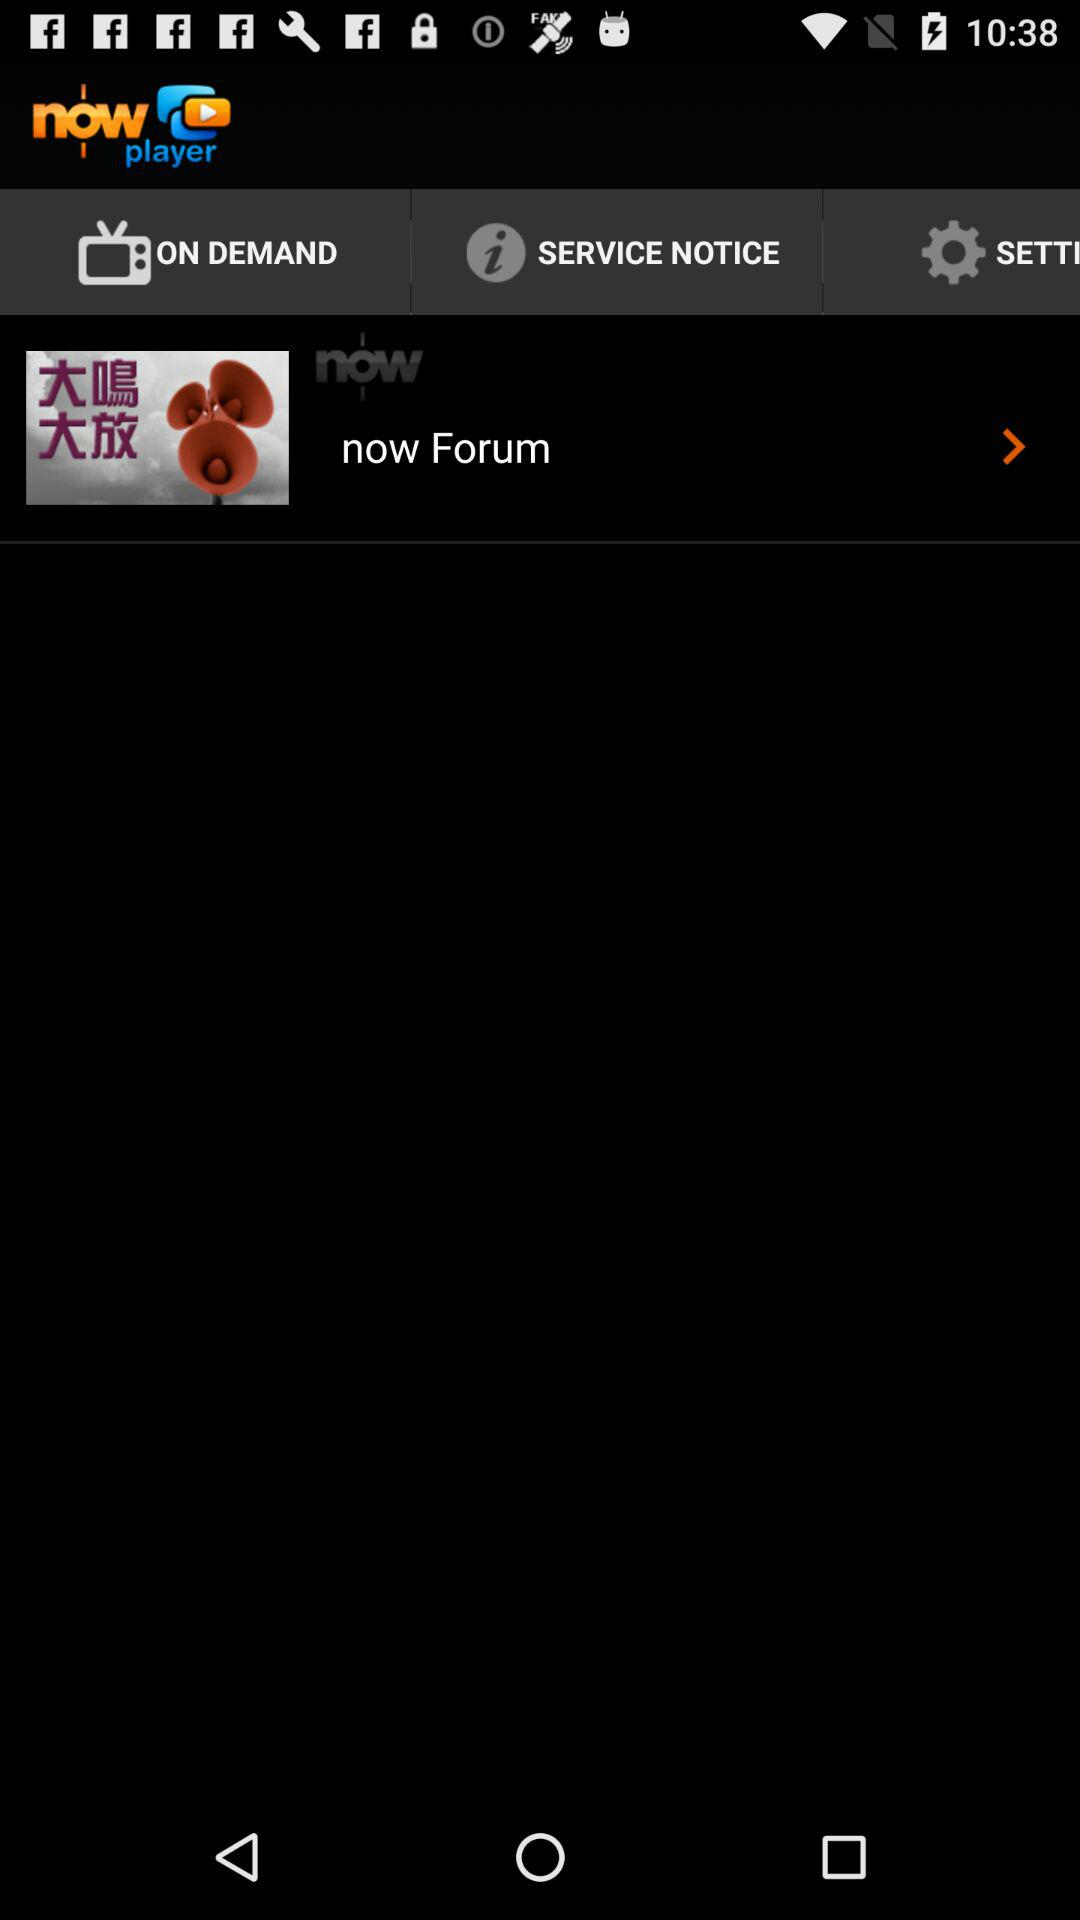What is the name of the application? The name of the application is "Now Player". 